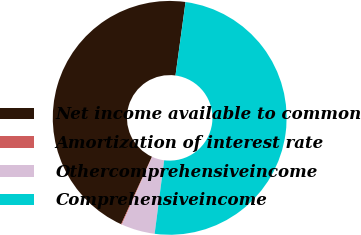Convert chart. <chart><loc_0><loc_0><loc_500><loc_500><pie_chart><fcel>Net income available to common<fcel>Amortization of interest rate<fcel>Othercomprehensiveincome<fcel>Comprehensiveincome<nl><fcel>45.35%<fcel>0.11%<fcel>4.65%<fcel>49.89%<nl></chart> 